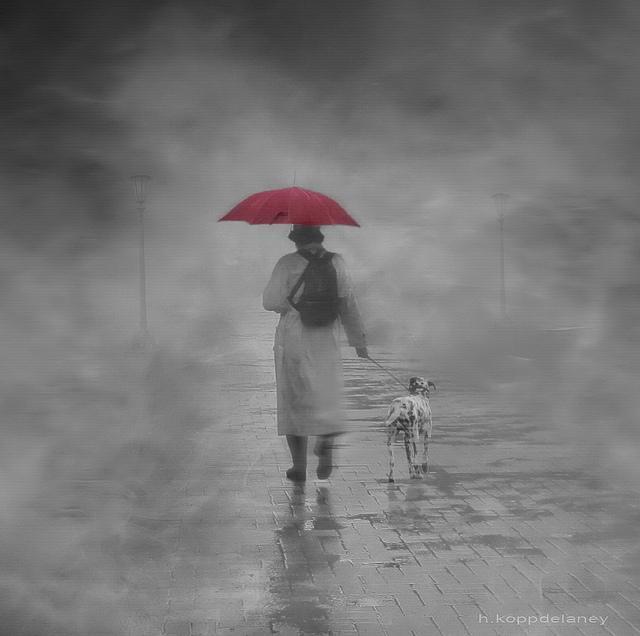How many backpacks can you see?
Give a very brief answer. 1. 